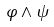Convert formula to latex. <formula><loc_0><loc_0><loc_500><loc_500>\varphi \wedge \psi</formula> 